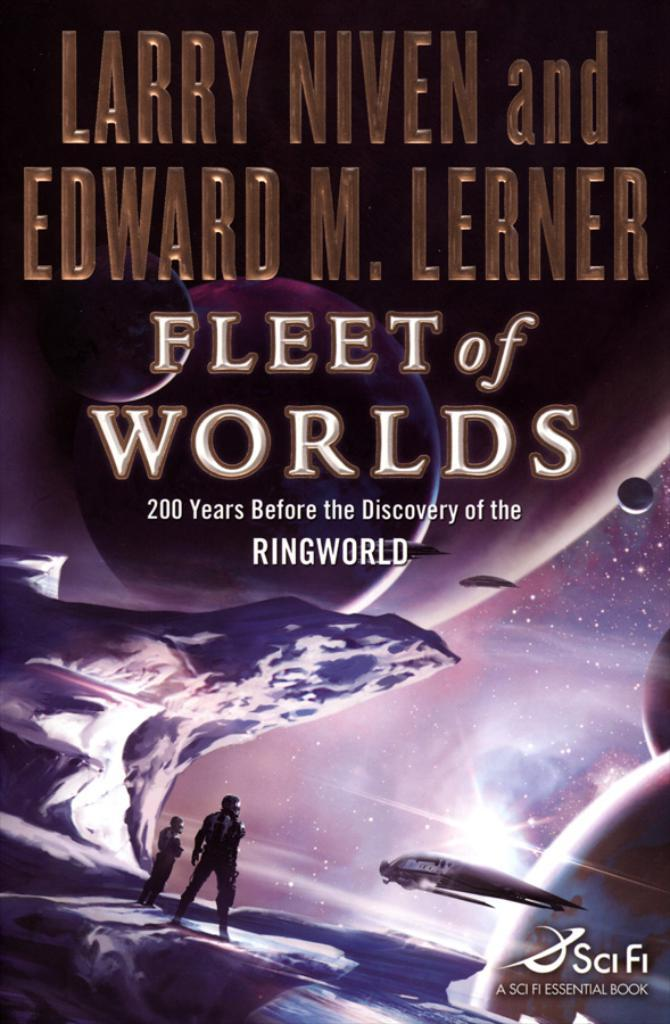<image>
Relay a brief, clear account of the picture shown. A book called Fleet of the Worlds by Larry Niven and Edward M. Lerner. 